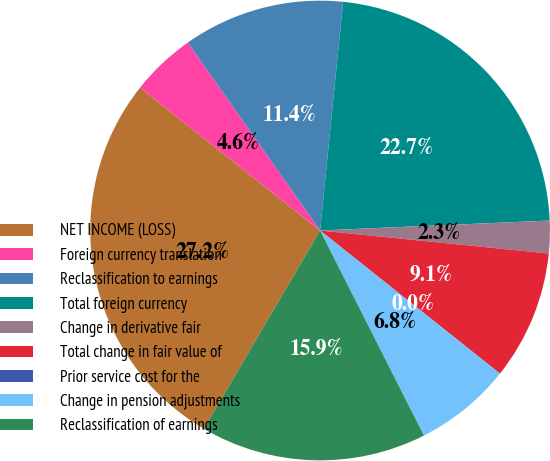Convert chart to OTSL. <chart><loc_0><loc_0><loc_500><loc_500><pie_chart><fcel>NET INCOME (LOSS)<fcel>Foreign currency translation<fcel>Reclassification to earnings<fcel>Total foreign currency<fcel>Change in derivative fair<fcel>Total change in fair value of<fcel>Prior service cost for the<fcel>Change in pension adjustments<fcel>Reclassification of earnings<nl><fcel>27.24%<fcel>4.56%<fcel>11.36%<fcel>22.71%<fcel>2.29%<fcel>9.09%<fcel>0.02%<fcel>6.83%<fcel>15.9%<nl></chart> 